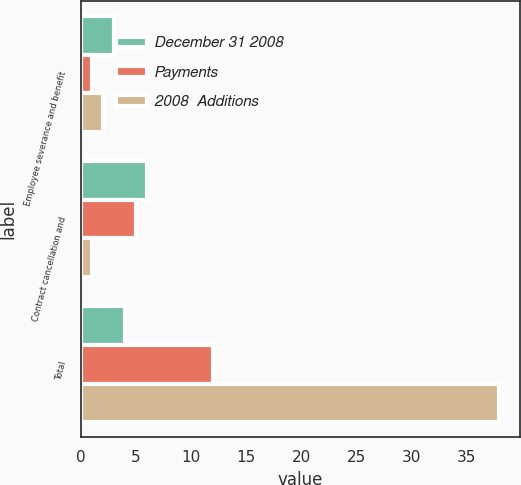Convert chart to OTSL. <chart><loc_0><loc_0><loc_500><loc_500><stacked_bar_chart><ecel><fcel>Employee severance and benefit<fcel>Contract cancellation and<fcel>Total<nl><fcel>December 31 2008<fcel>3<fcel>6<fcel>4<nl><fcel>Payments<fcel>1<fcel>5<fcel>12<nl><fcel>2008  Additions<fcel>2<fcel>1<fcel>38<nl></chart> 